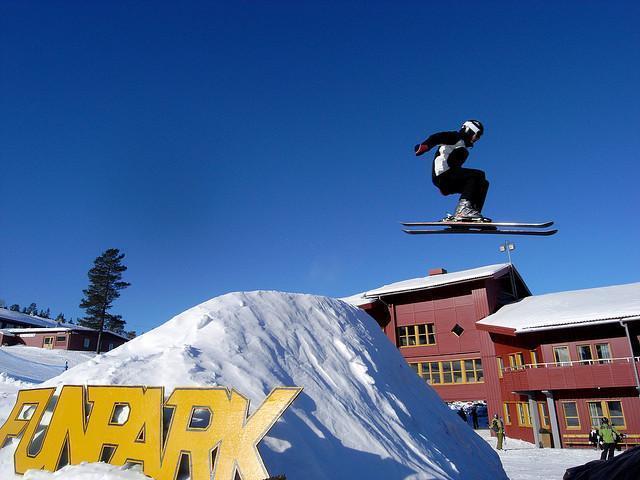What type of sign is shown?
Answer the question by selecting the correct answer among the 4 following choices.
Options: Regulatory, orientation, location, directional. Location. 